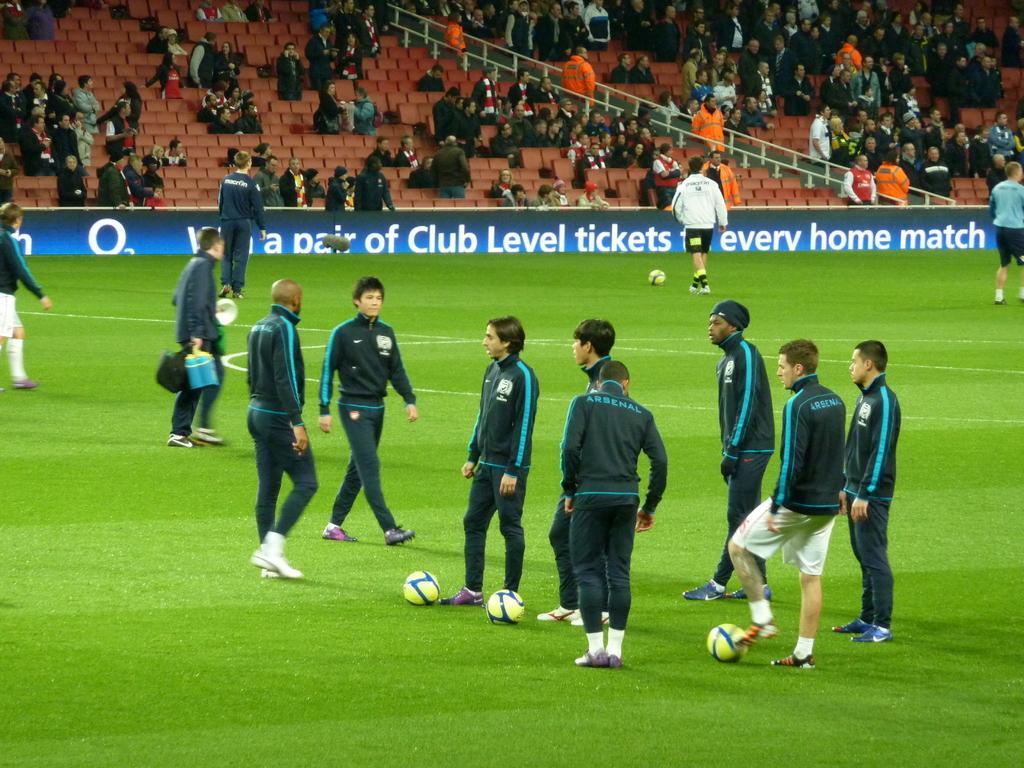Could you give a brief overview of what you see in this image? In this picture I can see football players standing in the playground and there are some balls on the ground and in the backdrop there are audience sitting in the chairs. 